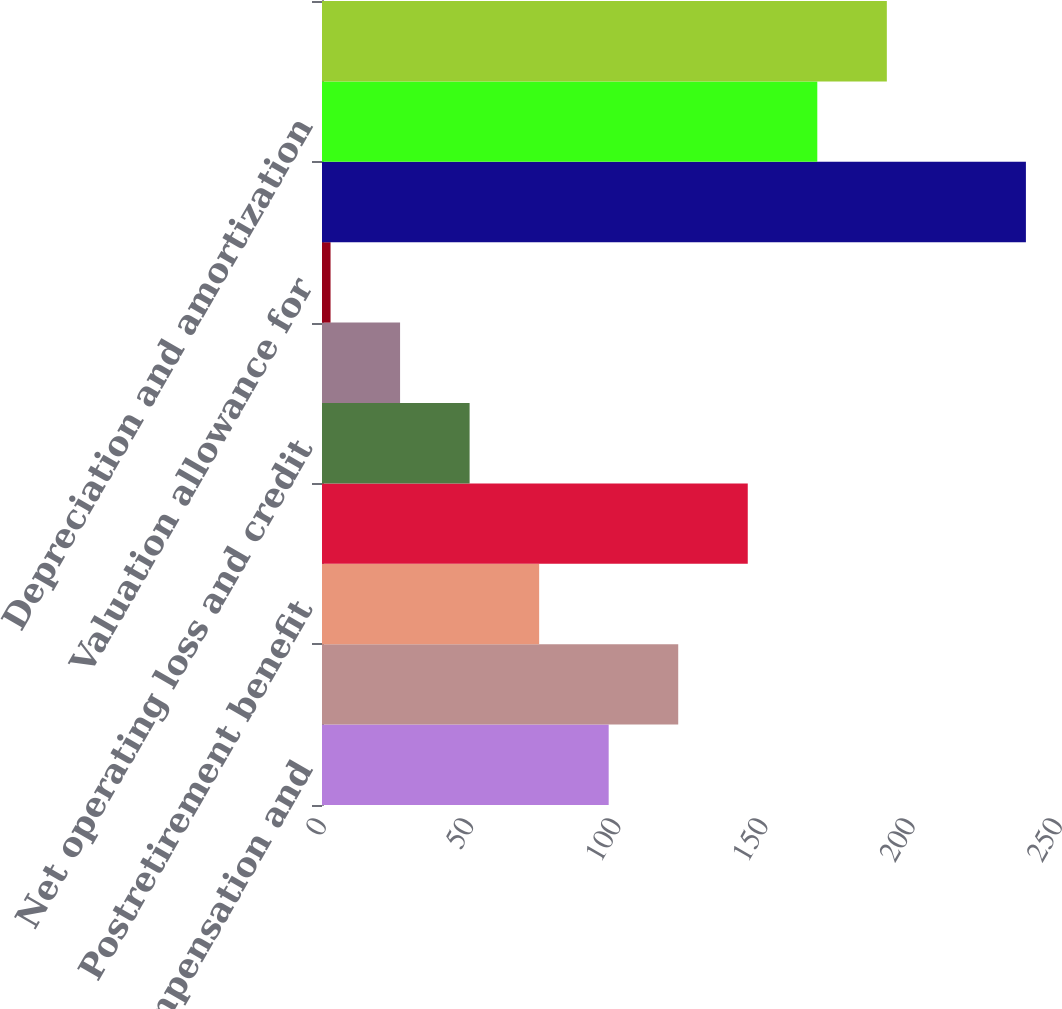Convert chart to OTSL. <chart><loc_0><loc_0><loc_500><loc_500><bar_chart><fcel>Deferred compensation and<fcel>Inventory obsolescence and<fcel>Postretirement benefit<fcel>Various accruals not currently<fcel>Net operating loss and credit<fcel>Other differences between tax<fcel>Valuation allowance for<fcel>Total deferred tax assets<fcel>Depreciation and amortization<fcel>Total deferred tax liabilities<nl><fcel>97.38<fcel>121<fcel>73.76<fcel>144.62<fcel>50.14<fcel>26.52<fcel>2.9<fcel>239.1<fcel>168.24<fcel>191.86<nl></chart> 